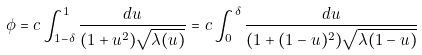<formula> <loc_0><loc_0><loc_500><loc_500>\phi = c \int _ { 1 - \delta } ^ { 1 } \frac { d u } { ( 1 + u ^ { 2 } ) \sqrt { \lambda ( u ) } } = c \int _ { 0 } ^ { \delta } \frac { d u } { ( 1 + ( 1 - u ) ^ { 2 } ) \sqrt { \lambda ( 1 - u ) } }</formula> 